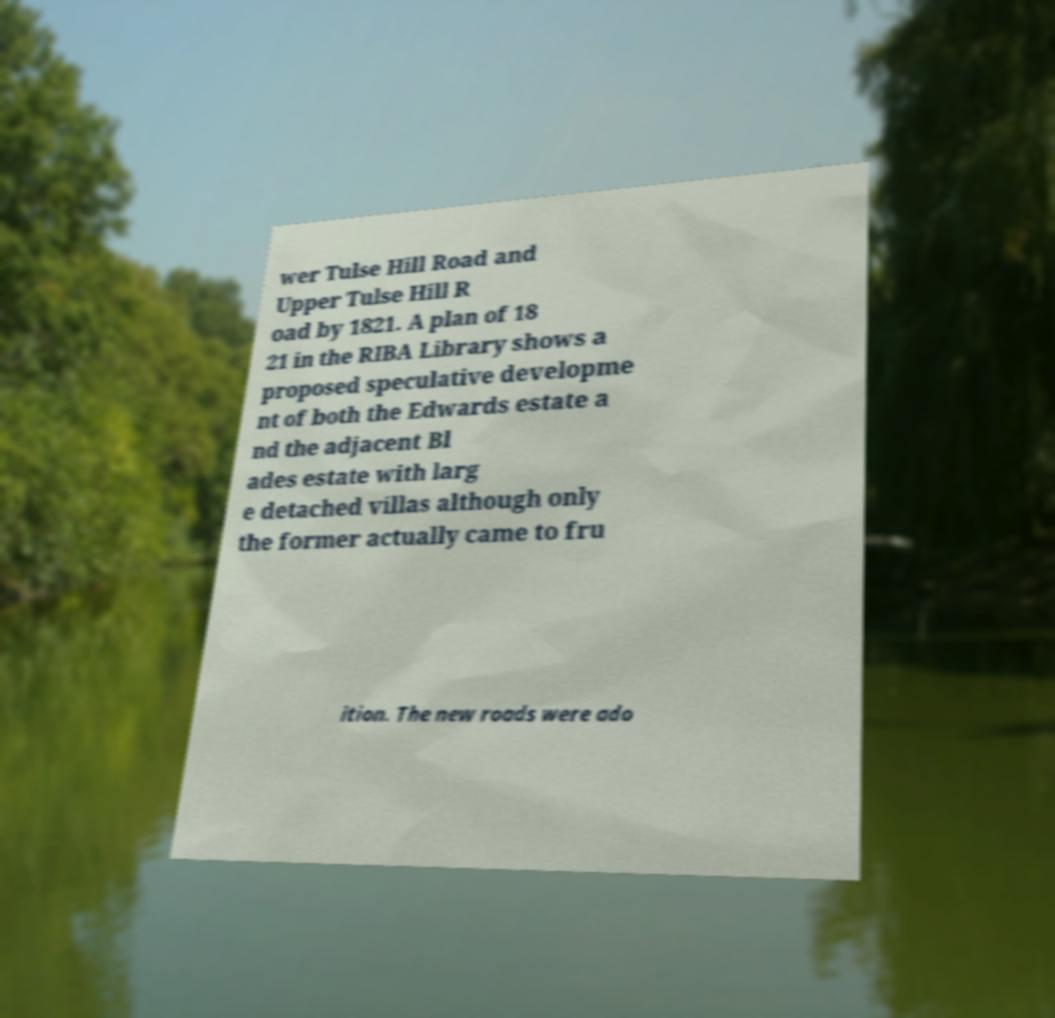Could you assist in decoding the text presented in this image and type it out clearly? wer Tulse Hill Road and Upper Tulse Hill R oad by 1821. A plan of 18 21 in the RIBA Library shows a proposed speculative developme nt of both the Edwards estate a nd the adjacent Bl ades estate with larg e detached villas although only the former actually came to fru ition. The new roads were ado 